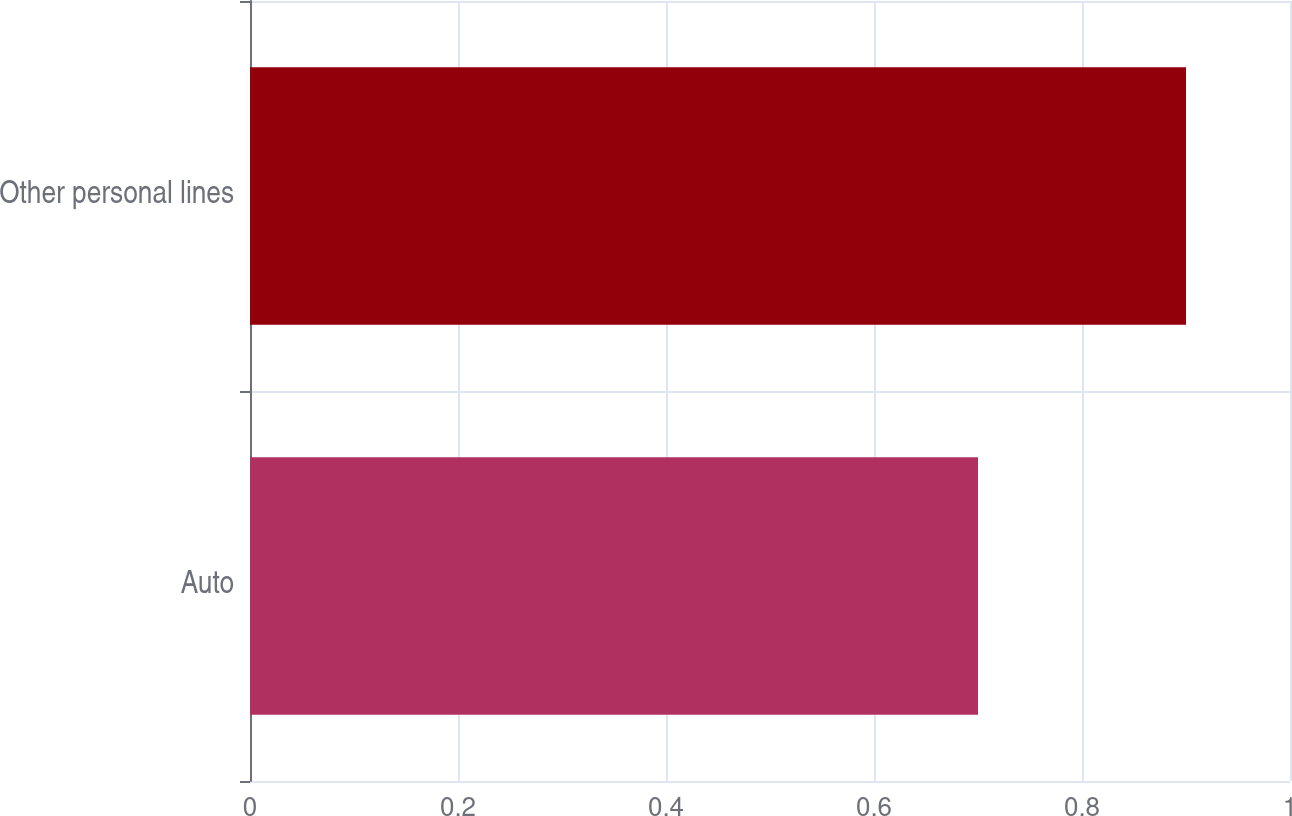Convert chart to OTSL. <chart><loc_0><loc_0><loc_500><loc_500><bar_chart><fcel>Auto<fcel>Other personal lines<nl><fcel>0.7<fcel>0.9<nl></chart> 